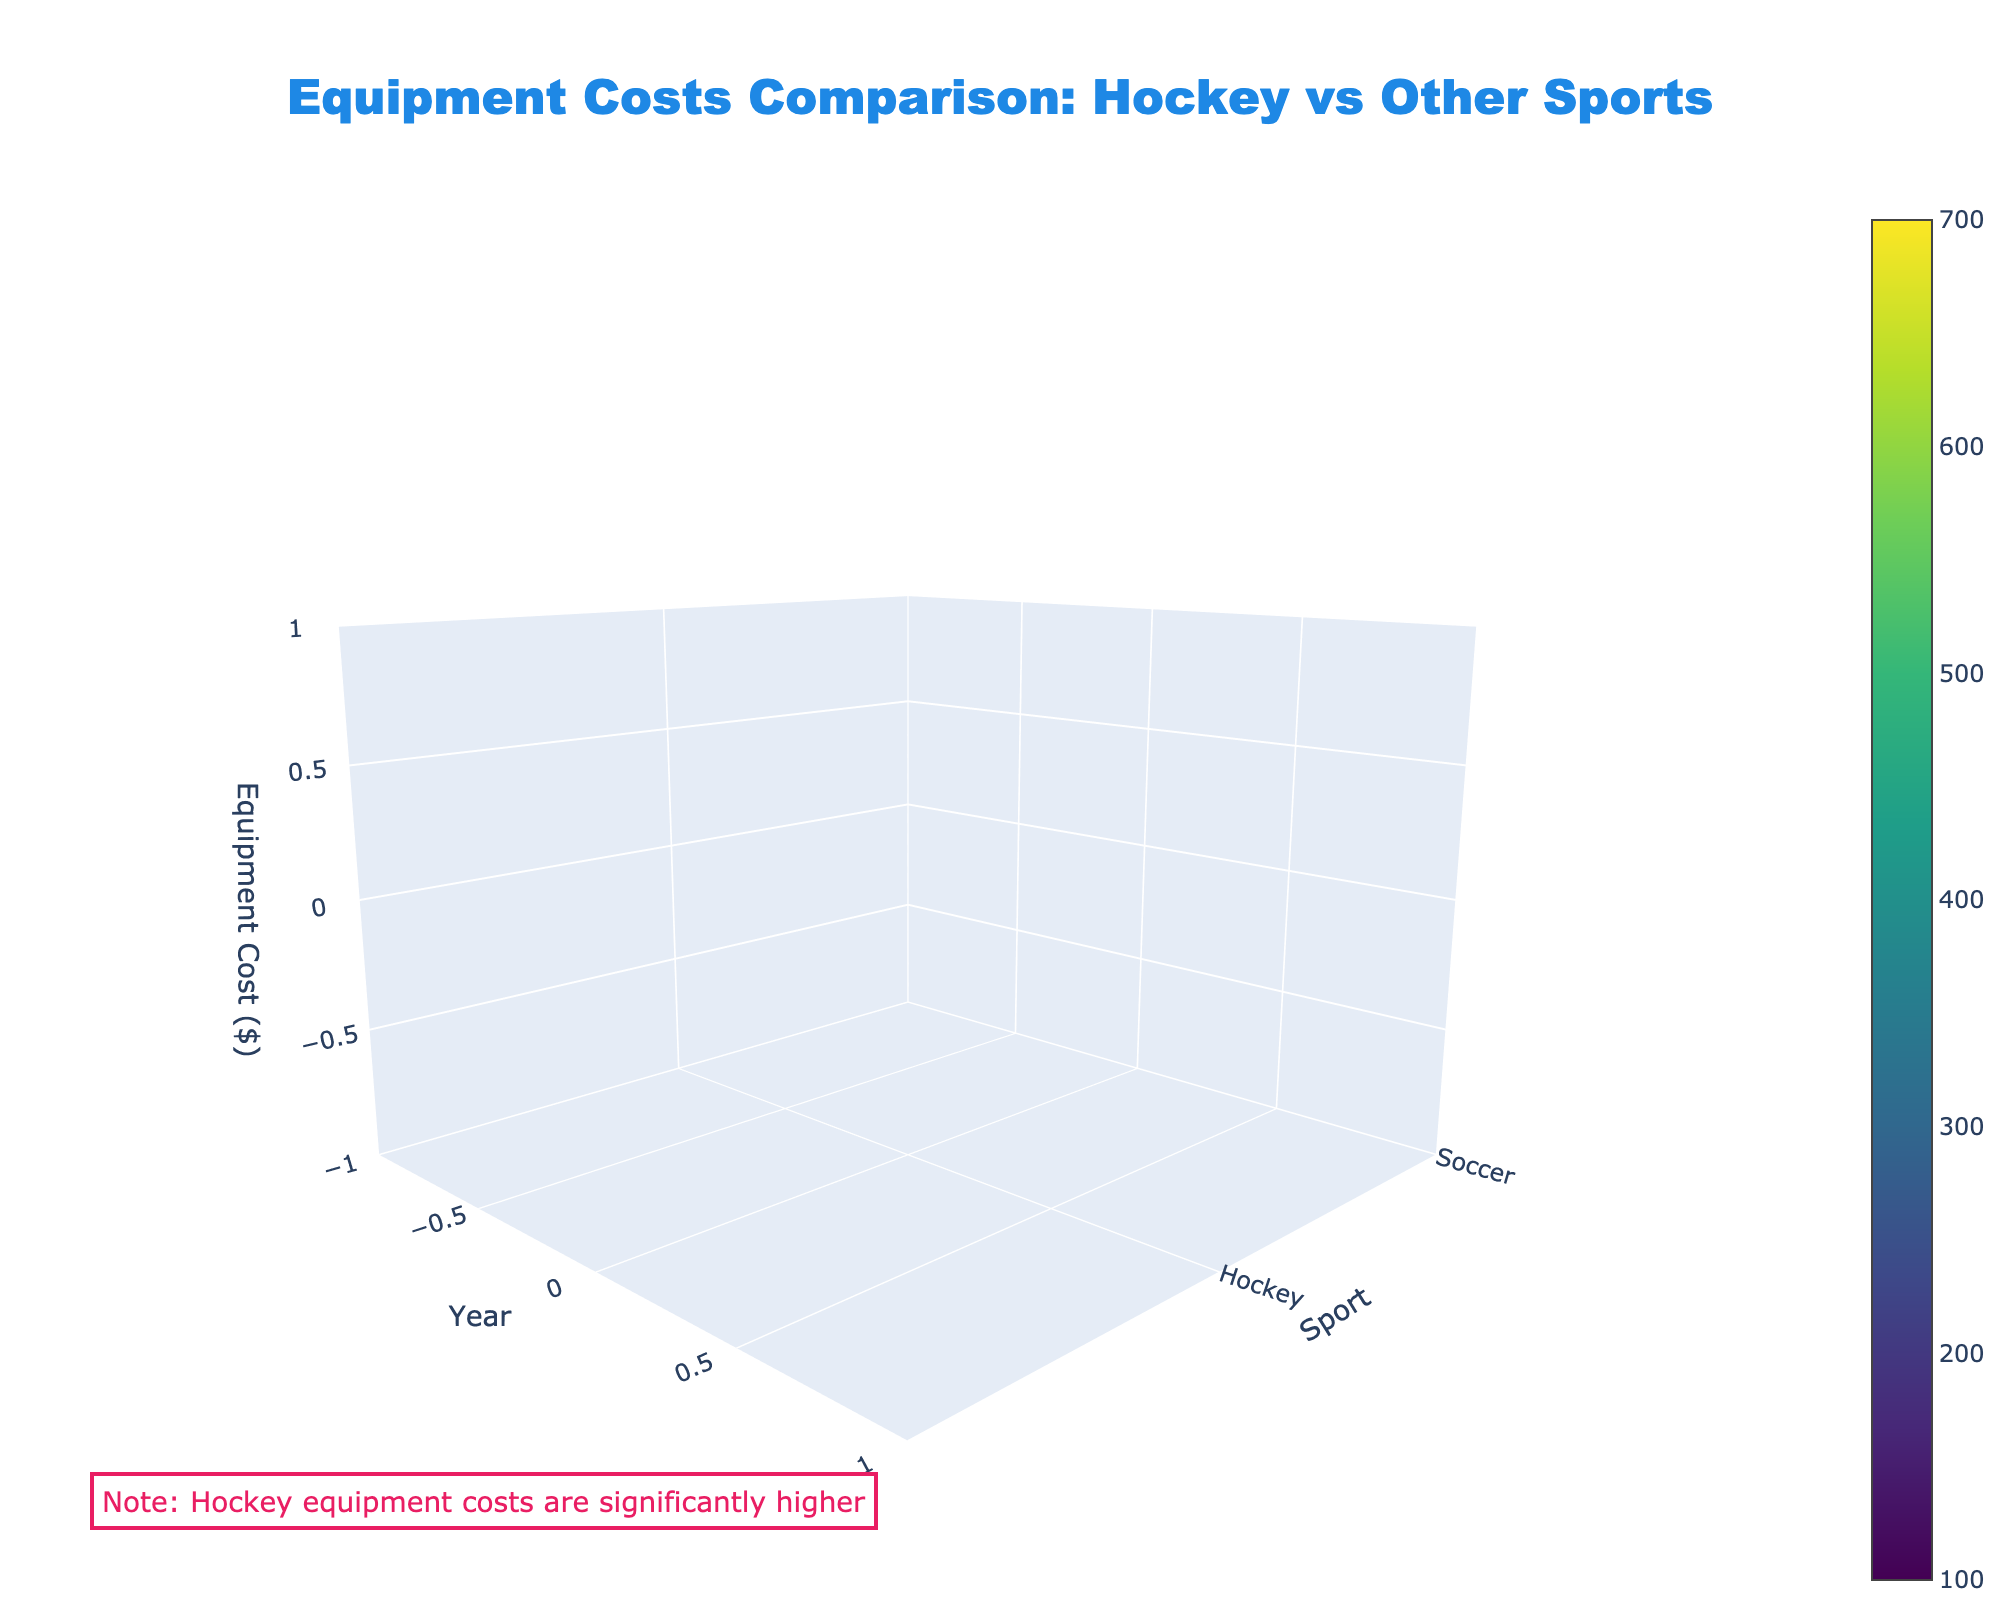1. What is the title of the plot? The title is located at the top of the plot, centered, and it reads clearly.
Answer: Equipment Costs Comparison: Hockey vs Other Sports 2. Which sport has the highest equipment cost in 2015? By looking at the 2015 data points on the z-axis for each sport, the highest cost is for Hockey.
Answer: Hockey 3. What is the equipment cost for Soccer in 2021? On the y-axis, find Soccer, and follow the corresponding column in the x-axis to 2021, then check the z-axis value.
Answer: $150 4. How does Basketball's equipment cost in 2023 compare to its cost in 2015? Locate 2015 and 2023 data points for Basketball on the y-axis and compare the z-axis values. The cost increases from 150 to 190.
Answer: It increased by $40 5. What trend do you notice in the equipment costs of Hockey from 2015 to 2023? Following the Hockey data points from 2015 to 2023 on the x-axis and checking their values on the z-axis, a consistent increase is observed.
Answer: Consistently increasing 6. Which year shows the highest equipment cost for Hockey, and what is the cost? Checking the z-axis values for Hockey at every x-axis year, the highest cost is in 2023.
Answer: 2023, $650 7. Compare the trend in equipment costs for Soccer and Basketball over the years? Examine the data points of Soccer and Basketball on the z-axis for each year. Both trends show consistent but gradual increases.
Answer: Both increased gradually 8. What is the difference in the equipment cost between Soccer and Hockey in 2019? Locate 2019 on the x-axis for both Soccer and Hockey, and subtract Soccer’s cost from Hockey’s on the z-axis.
Answer: $410 9. Does any sport have an equipment cost above $600 in 2021? Checking the z-axis values for each sport in 2021 reveals only Hockey exceeds $600.
Answer: Only Hockey 10. Which sport has the lowest equipment cost in any given year and what is the year? By analyzing the minimum z-axis value for all sports, Soccer in 2015 has the lowest cost.
Answer: Soccer, 2015 ($120) 